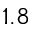<formula> <loc_0><loc_0><loc_500><loc_500>1 . 8</formula> 